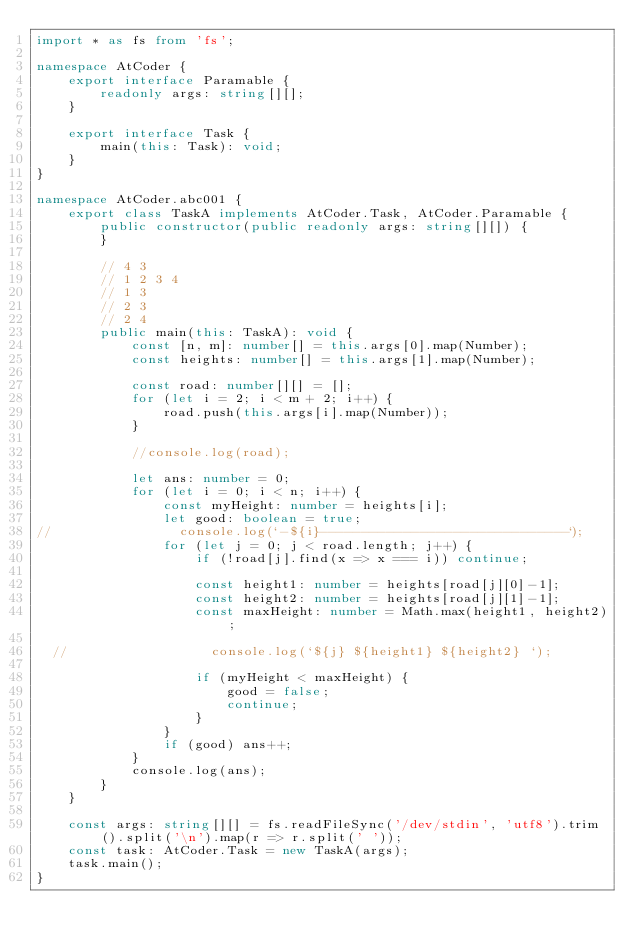<code> <loc_0><loc_0><loc_500><loc_500><_TypeScript_>import * as fs from 'fs';

namespace AtCoder {
    export interface Paramable {
        readonly args: string[][];
    }

    export interface Task {
        main(this: Task): void;
    }
}

namespace AtCoder.abc001 {
    export class TaskA implements AtCoder.Task, AtCoder.Paramable {
        public constructor(public readonly args: string[][]) {
        }

        // 4 3
        // 1 2 3 4
        // 1 3
        // 2 3
        // 2 4
        public main(this: TaskA): void {
            const [n, m]: number[] = this.args[0].map(Number);
            const heights: number[] = this.args[1].map(Number);

            const road: number[][] = [];
            for (let i = 2; i < m + 2; i++) {
                road.push(this.args[i].map(Number));
            }

            //console.log(road);

            let ans: number = 0;
            for (let i = 0; i < n; i++) {
                const myHeight: number = heights[i];
                let good: boolean = true;
//                console.log(`-${i}------------------------------`);
                for (let j = 0; j < road.length; j++) {
                    if (!road[j].find(x => x === i)) continue;

                    const height1: number = heights[road[j][0]-1];
                    const height2: number = heights[road[j][1]-1];
                    const maxHeight: number = Math.max(height1, height2);

  //                  console.log(`${j} ${height1} ${height2} `);

                    if (myHeight < maxHeight) {
                        good = false;
                        continue;
                    }
                }
                if (good) ans++;
            }
            console.log(ans);
        }
    }

    const args: string[][] = fs.readFileSync('/dev/stdin', 'utf8').trim().split('\n').map(r => r.split(' '));
    const task: AtCoder.Task = new TaskA(args);
    task.main();
}

</code> 